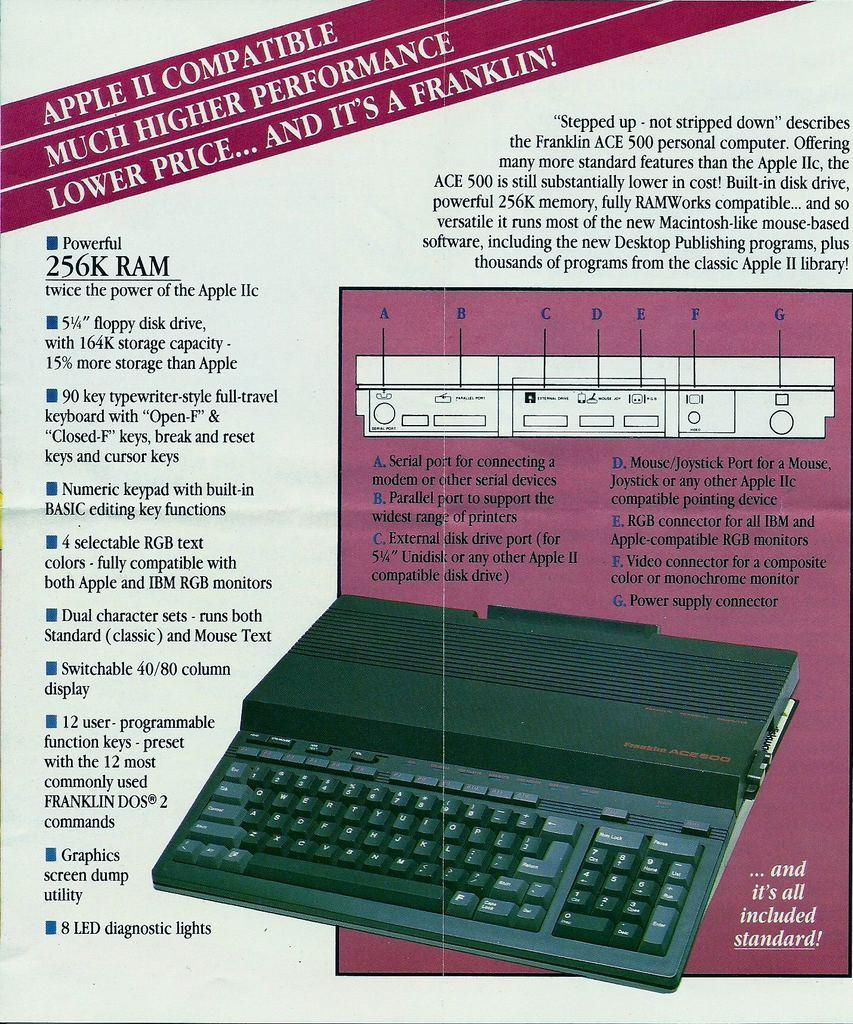<image>
Relay a brief, clear account of the picture shown. Poster for a keyboard that says it's Apple II compatible. 